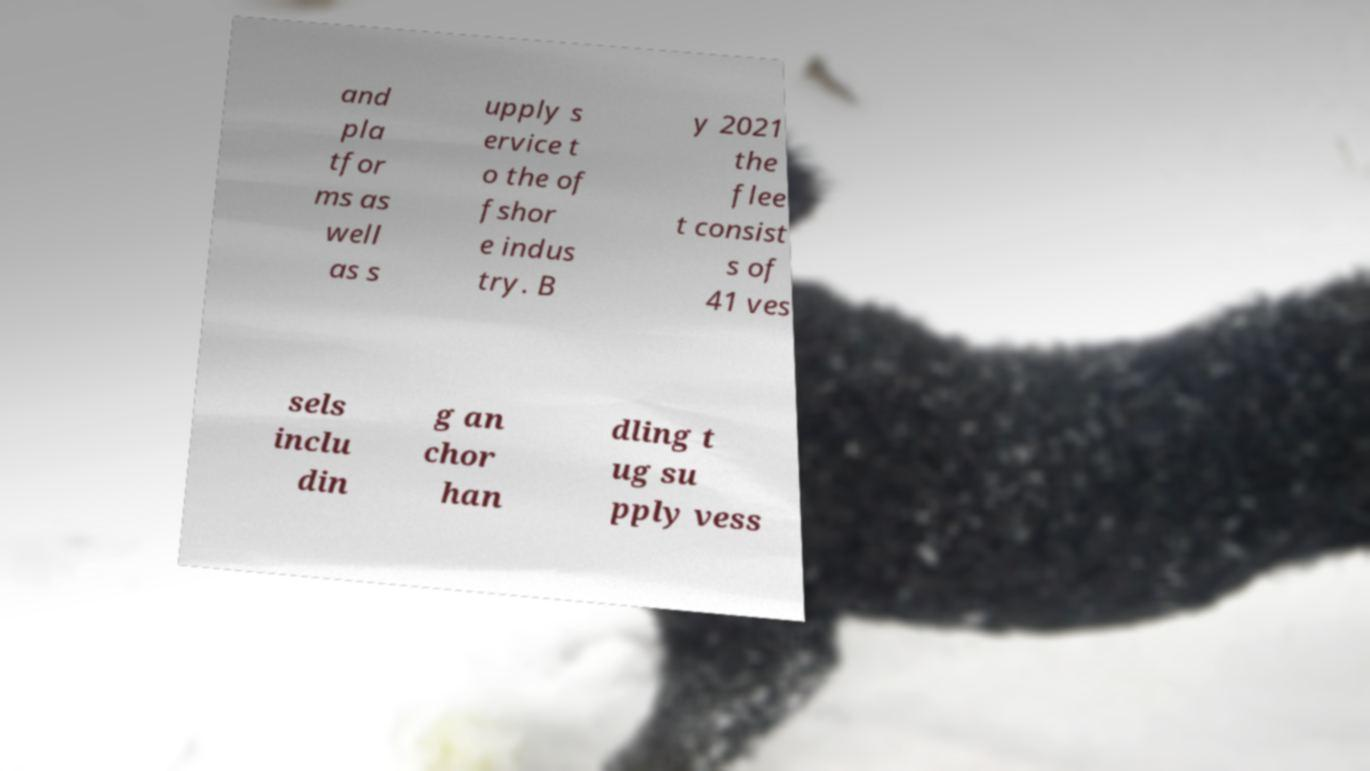Can you read and provide the text displayed in the image?This photo seems to have some interesting text. Can you extract and type it out for me? and pla tfor ms as well as s upply s ervice t o the of fshor e indus try. B y 2021 the flee t consist s of 41 ves sels inclu din g an chor han dling t ug su pply vess 